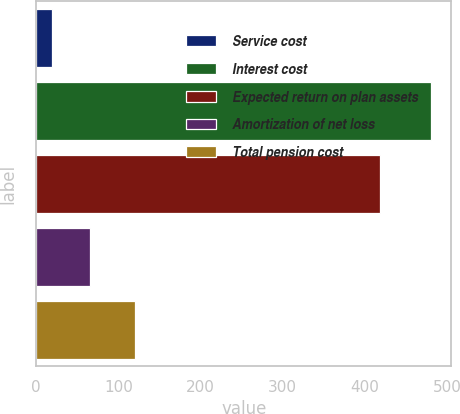Convert chart. <chart><loc_0><loc_0><loc_500><loc_500><bar_chart><fcel>Service cost<fcel>Interest cost<fcel>Expected return on plan assets<fcel>Amortization of net loss<fcel>Total pension cost<nl><fcel>19<fcel>481<fcel>418<fcel>65.2<fcel>120<nl></chart> 